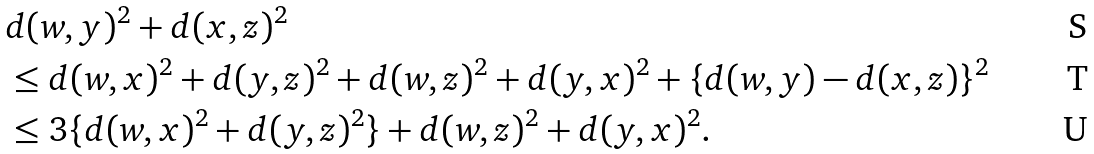Convert formula to latex. <formula><loc_0><loc_0><loc_500><loc_500>& d ( w , y ) ^ { 2 } + d ( x , z ) ^ { 2 } \\ & \leq d ( w , x ) ^ { 2 } + d ( y , z ) ^ { 2 } + d ( w , z ) ^ { 2 } + d ( y , x ) ^ { 2 } + \{ d ( w , y ) - d ( x , z ) \} ^ { 2 } \\ & \leq 3 \{ d ( w , x ) ^ { 2 } + d ( y , z ) ^ { 2 } \} + d ( w , z ) ^ { 2 } + d ( y , x ) ^ { 2 } .</formula> 